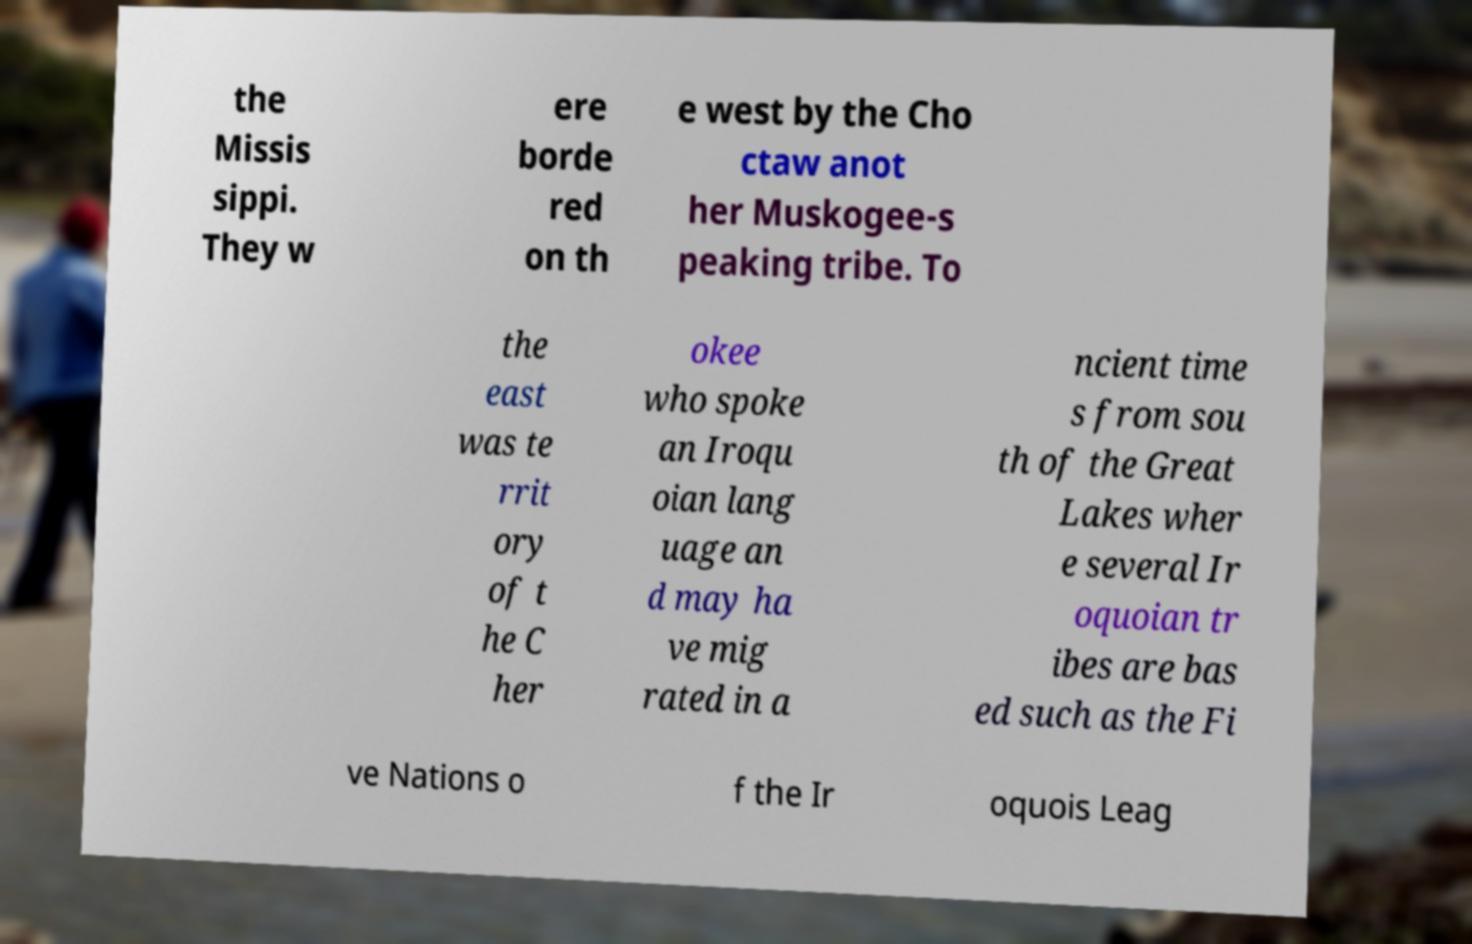I need the written content from this picture converted into text. Can you do that? the Missis sippi. They w ere borde red on th e west by the Cho ctaw anot her Muskogee-s peaking tribe. To the east was te rrit ory of t he C her okee who spoke an Iroqu oian lang uage an d may ha ve mig rated in a ncient time s from sou th of the Great Lakes wher e several Ir oquoian tr ibes are bas ed such as the Fi ve Nations o f the Ir oquois Leag 